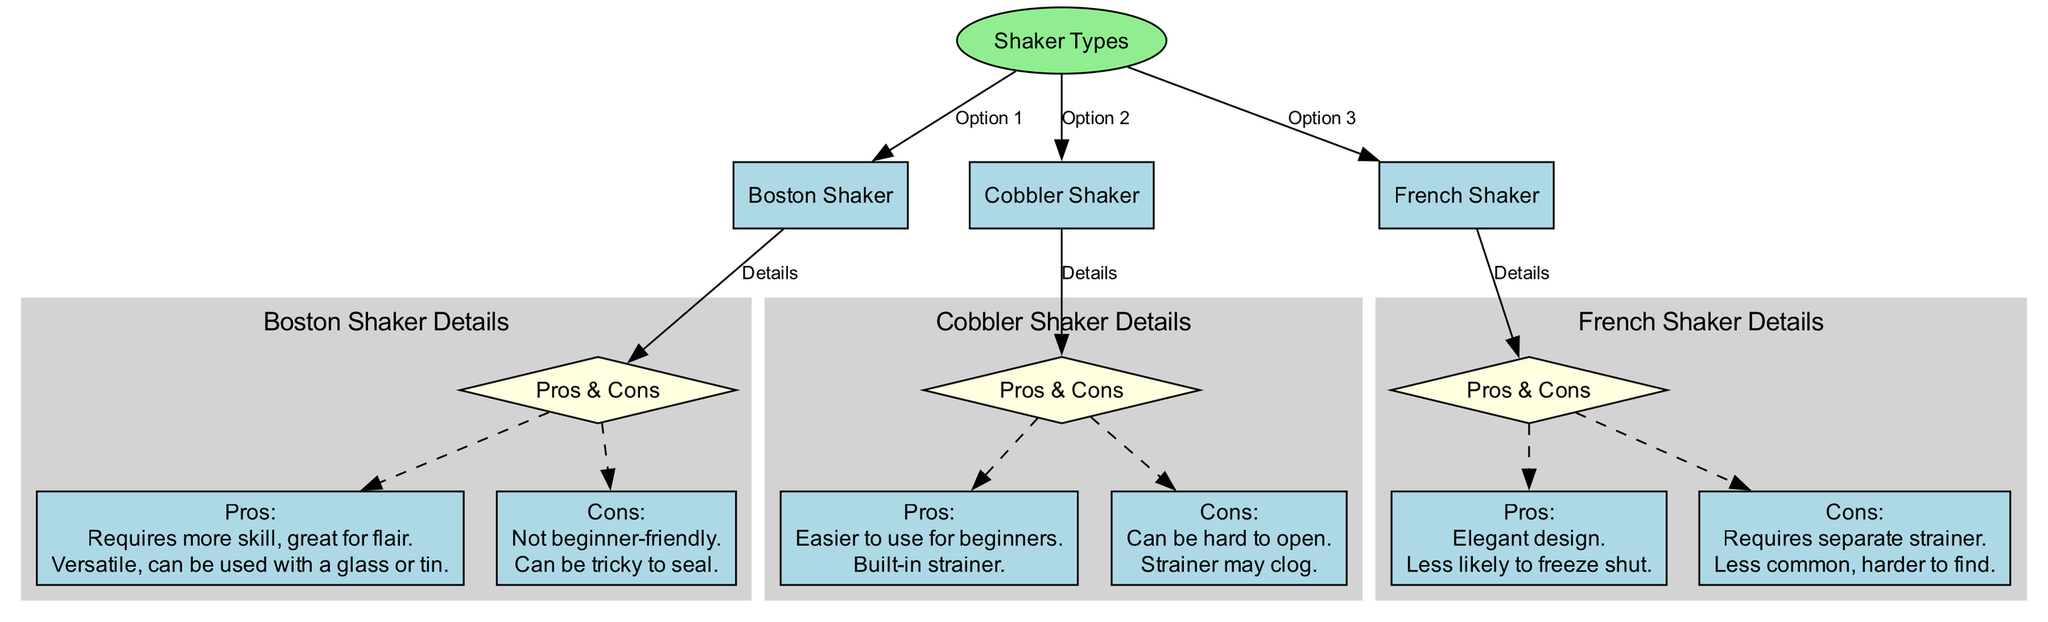What are the three types of shakers shown? The diagram lists three types of shakers: Boston Shaker, Cobbler Shaker, and French Shaker.
Answer: Boston Shaker, Cobbler Shaker, French Shaker Which shaker requires more skill? According to the pros of the Boston Shaker, it requires more skill, making it great for flair bartending.
Answer: Boston Shaker What is the unique feature of the Cobbler Shaker? The Cobbler Shaker has a built-in strainer as part of its design, making it easier to use, especially for beginners.
Answer: Built-in strainer How many total nodes are present in the diagram? Counting all the individual shaker nodes along with their pros and cons, there are a total of seven nodes in the diagram: three shakers and their pros and cons.
Answer: Seven Which shaker is described as elegant? The diagram mentions that the French Shaker has an elegant design in its pros.
Answer: French Shaker What is a common issue with the Cobbler Shaker? The Cobbler Shaker is noted to have a common issue of being hard to open, listed in the cons.
Answer: Hard to open Which shaker is less common and harder to find? The diagram indicates that the French Shaker is less common and harder to find.
Answer: French Shaker For how many shakers are pros and cons provided? The diagram provides pros and cons for three shakers: Boston Shaker, Cobbler Shaker, and French Shaker, indicating a detailed analysis for each.
Answer: Three 